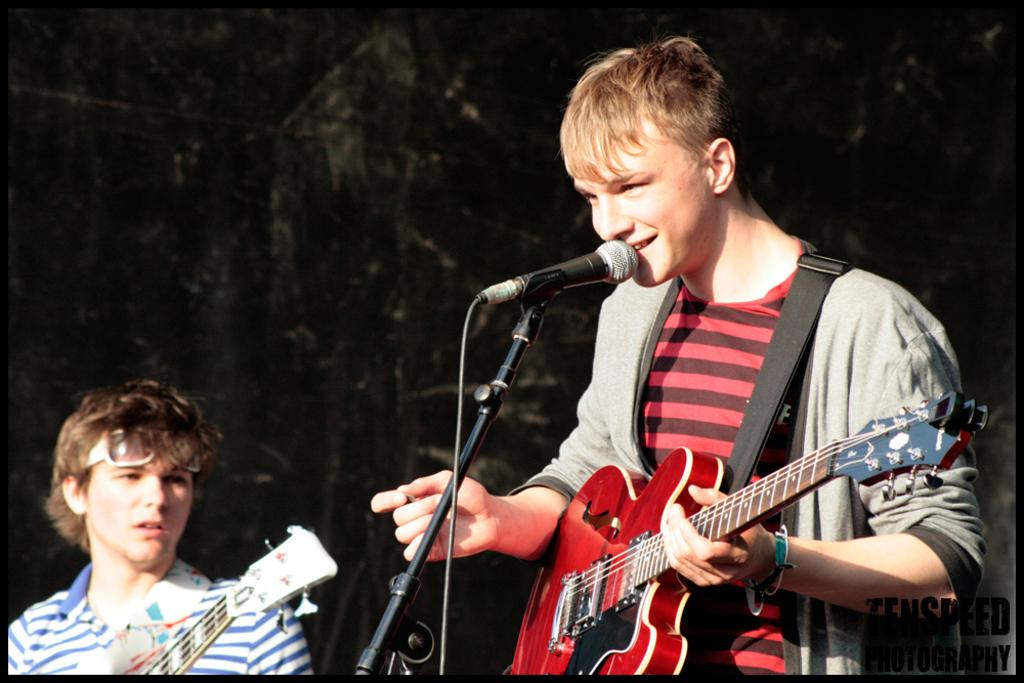What is the man in the image doing? The man is holding a guitar and singing into a microphone. Who is the man performing for in the image? There is a person looking at the man in the image. What can be inferred about the lighting conditions in the image? The background of the image is dark. What type of chin is visible on the apple in the image? There is no apple or chin present in the image. 